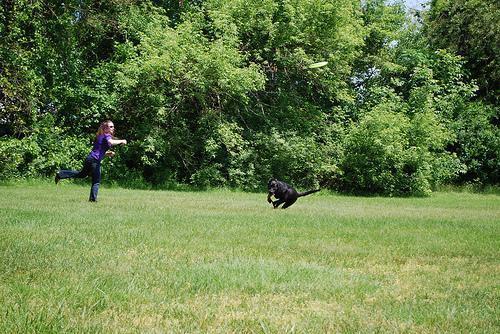How many dogs are shown?
Give a very brief answer. 1. How many people are pictured?
Give a very brief answer. 1. 